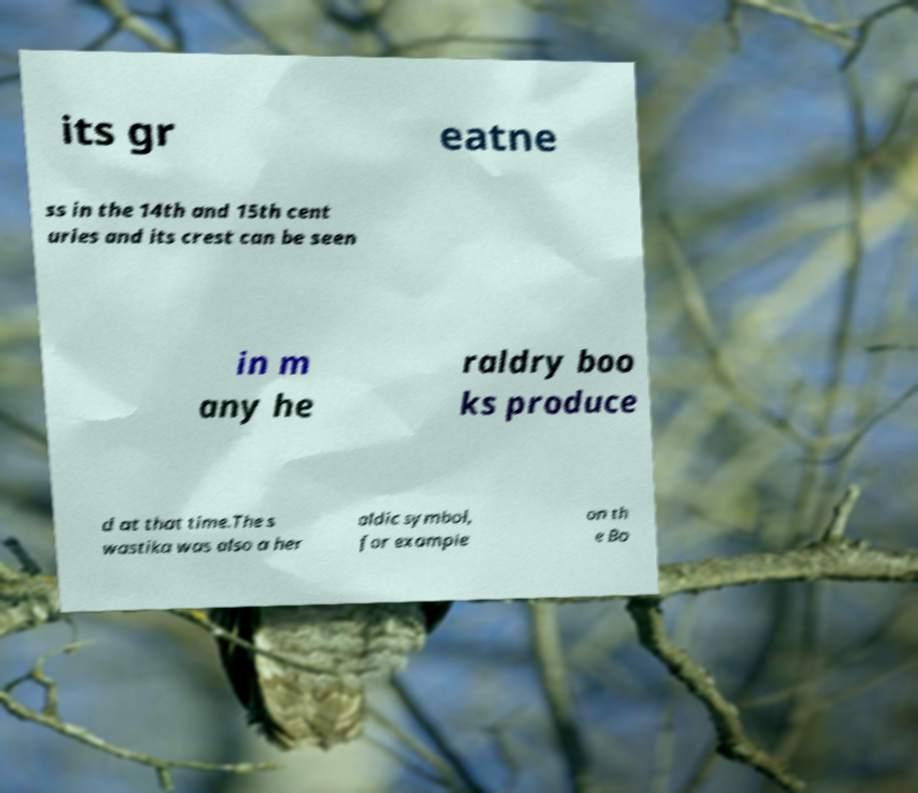Please identify and transcribe the text found in this image. its gr eatne ss in the 14th and 15th cent uries and its crest can be seen in m any he raldry boo ks produce d at that time.The s wastika was also a her aldic symbol, for example on th e Bo 